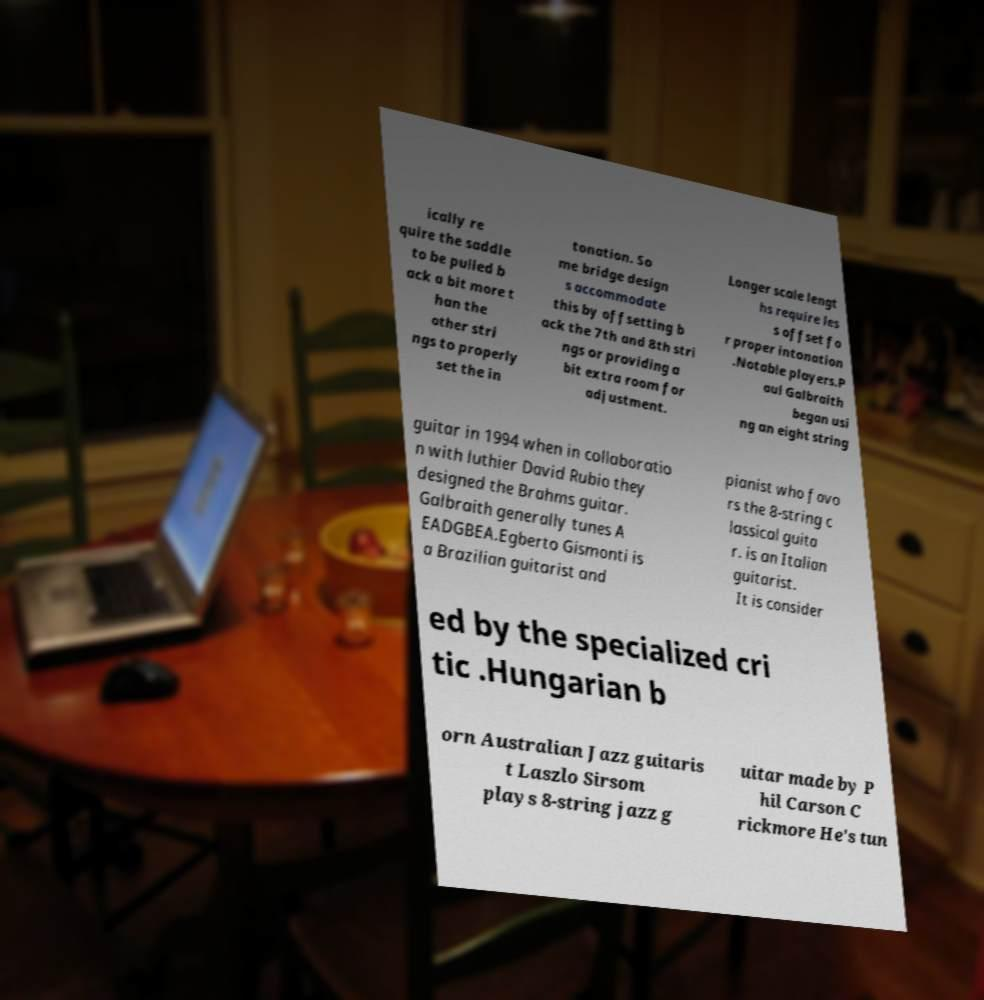Could you assist in decoding the text presented in this image and type it out clearly? ically re quire the saddle to be pulled b ack a bit more t han the other stri ngs to properly set the in tonation. So me bridge design s accommodate this by offsetting b ack the 7th and 8th stri ngs or providing a bit extra room for adjustment. Longer scale lengt hs require les s offset fo r proper intonation .Notable players.P aul Galbraith began usi ng an eight string guitar in 1994 when in collaboratio n with luthier David Rubio they designed the Brahms guitar. Galbraith generally tunes A EADGBEA.Egberto Gismonti is a Brazilian guitarist and pianist who favo rs the 8-string c lassical guita r. is an Italian guitarist. It is consider ed by the specialized cri tic .Hungarian b orn Australian Jazz guitaris t Laszlo Sirsom plays 8-string jazz g uitar made by P hil Carson C rickmore He's tun 